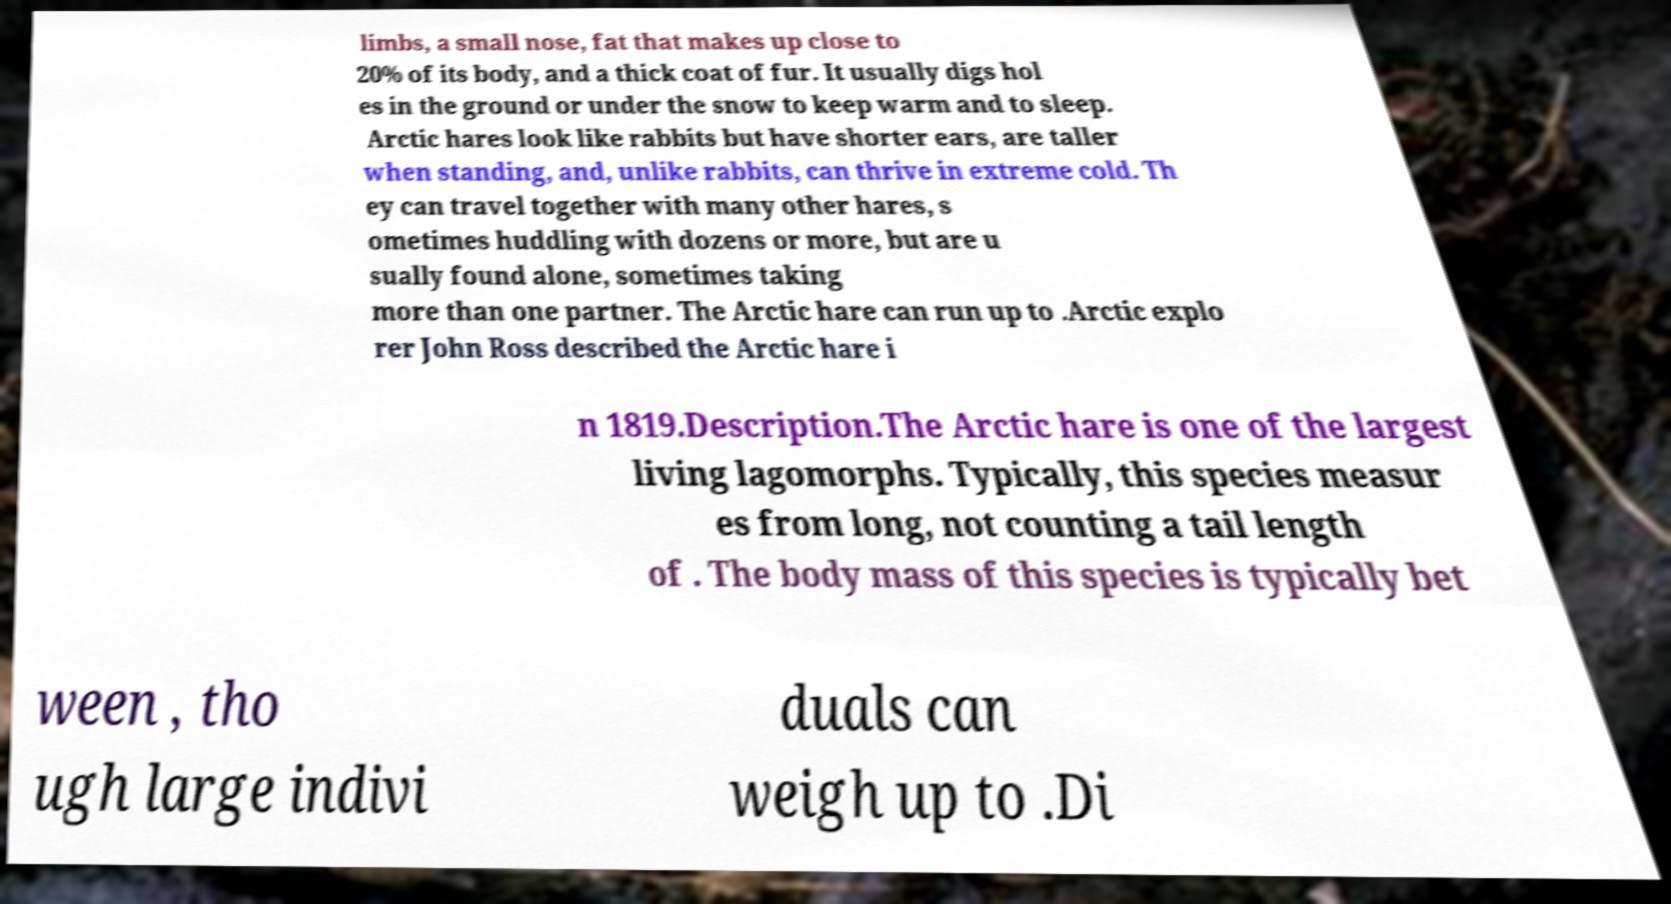I need the written content from this picture converted into text. Can you do that? limbs, a small nose, fat that makes up close to 20% of its body, and a thick coat of fur. It usually digs hol es in the ground or under the snow to keep warm and to sleep. Arctic hares look like rabbits but have shorter ears, are taller when standing, and, unlike rabbits, can thrive in extreme cold. Th ey can travel together with many other hares, s ometimes huddling with dozens or more, but are u sually found alone, sometimes taking more than one partner. The Arctic hare can run up to .Arctic explo rer John Ross described the Arctic hare i n 1819.Description.The Arctic hare is one of the largest living lagomorphs. Typically, this species measur es from long, not counting a tail length of . The body mass of this species is typically bet ween , tho ugh large indivi duals can weigh up to .Di 